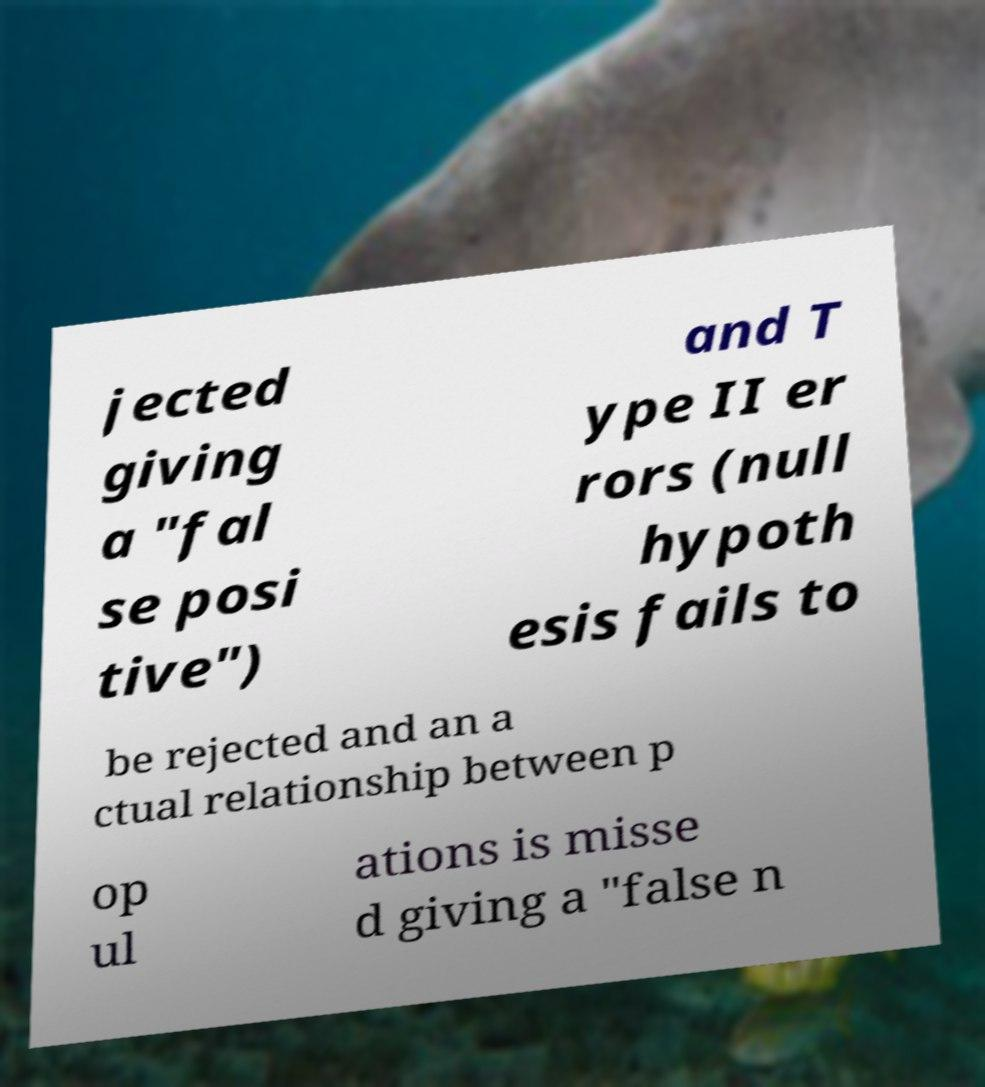Can you accurately transcribe the text from the provided image for me? jected giving a "fal se posi tive") and T ype II er rors (null hypoth esis fails to be rejected and an a ctual relationship between p op ul ations is misse d giving a "false n 